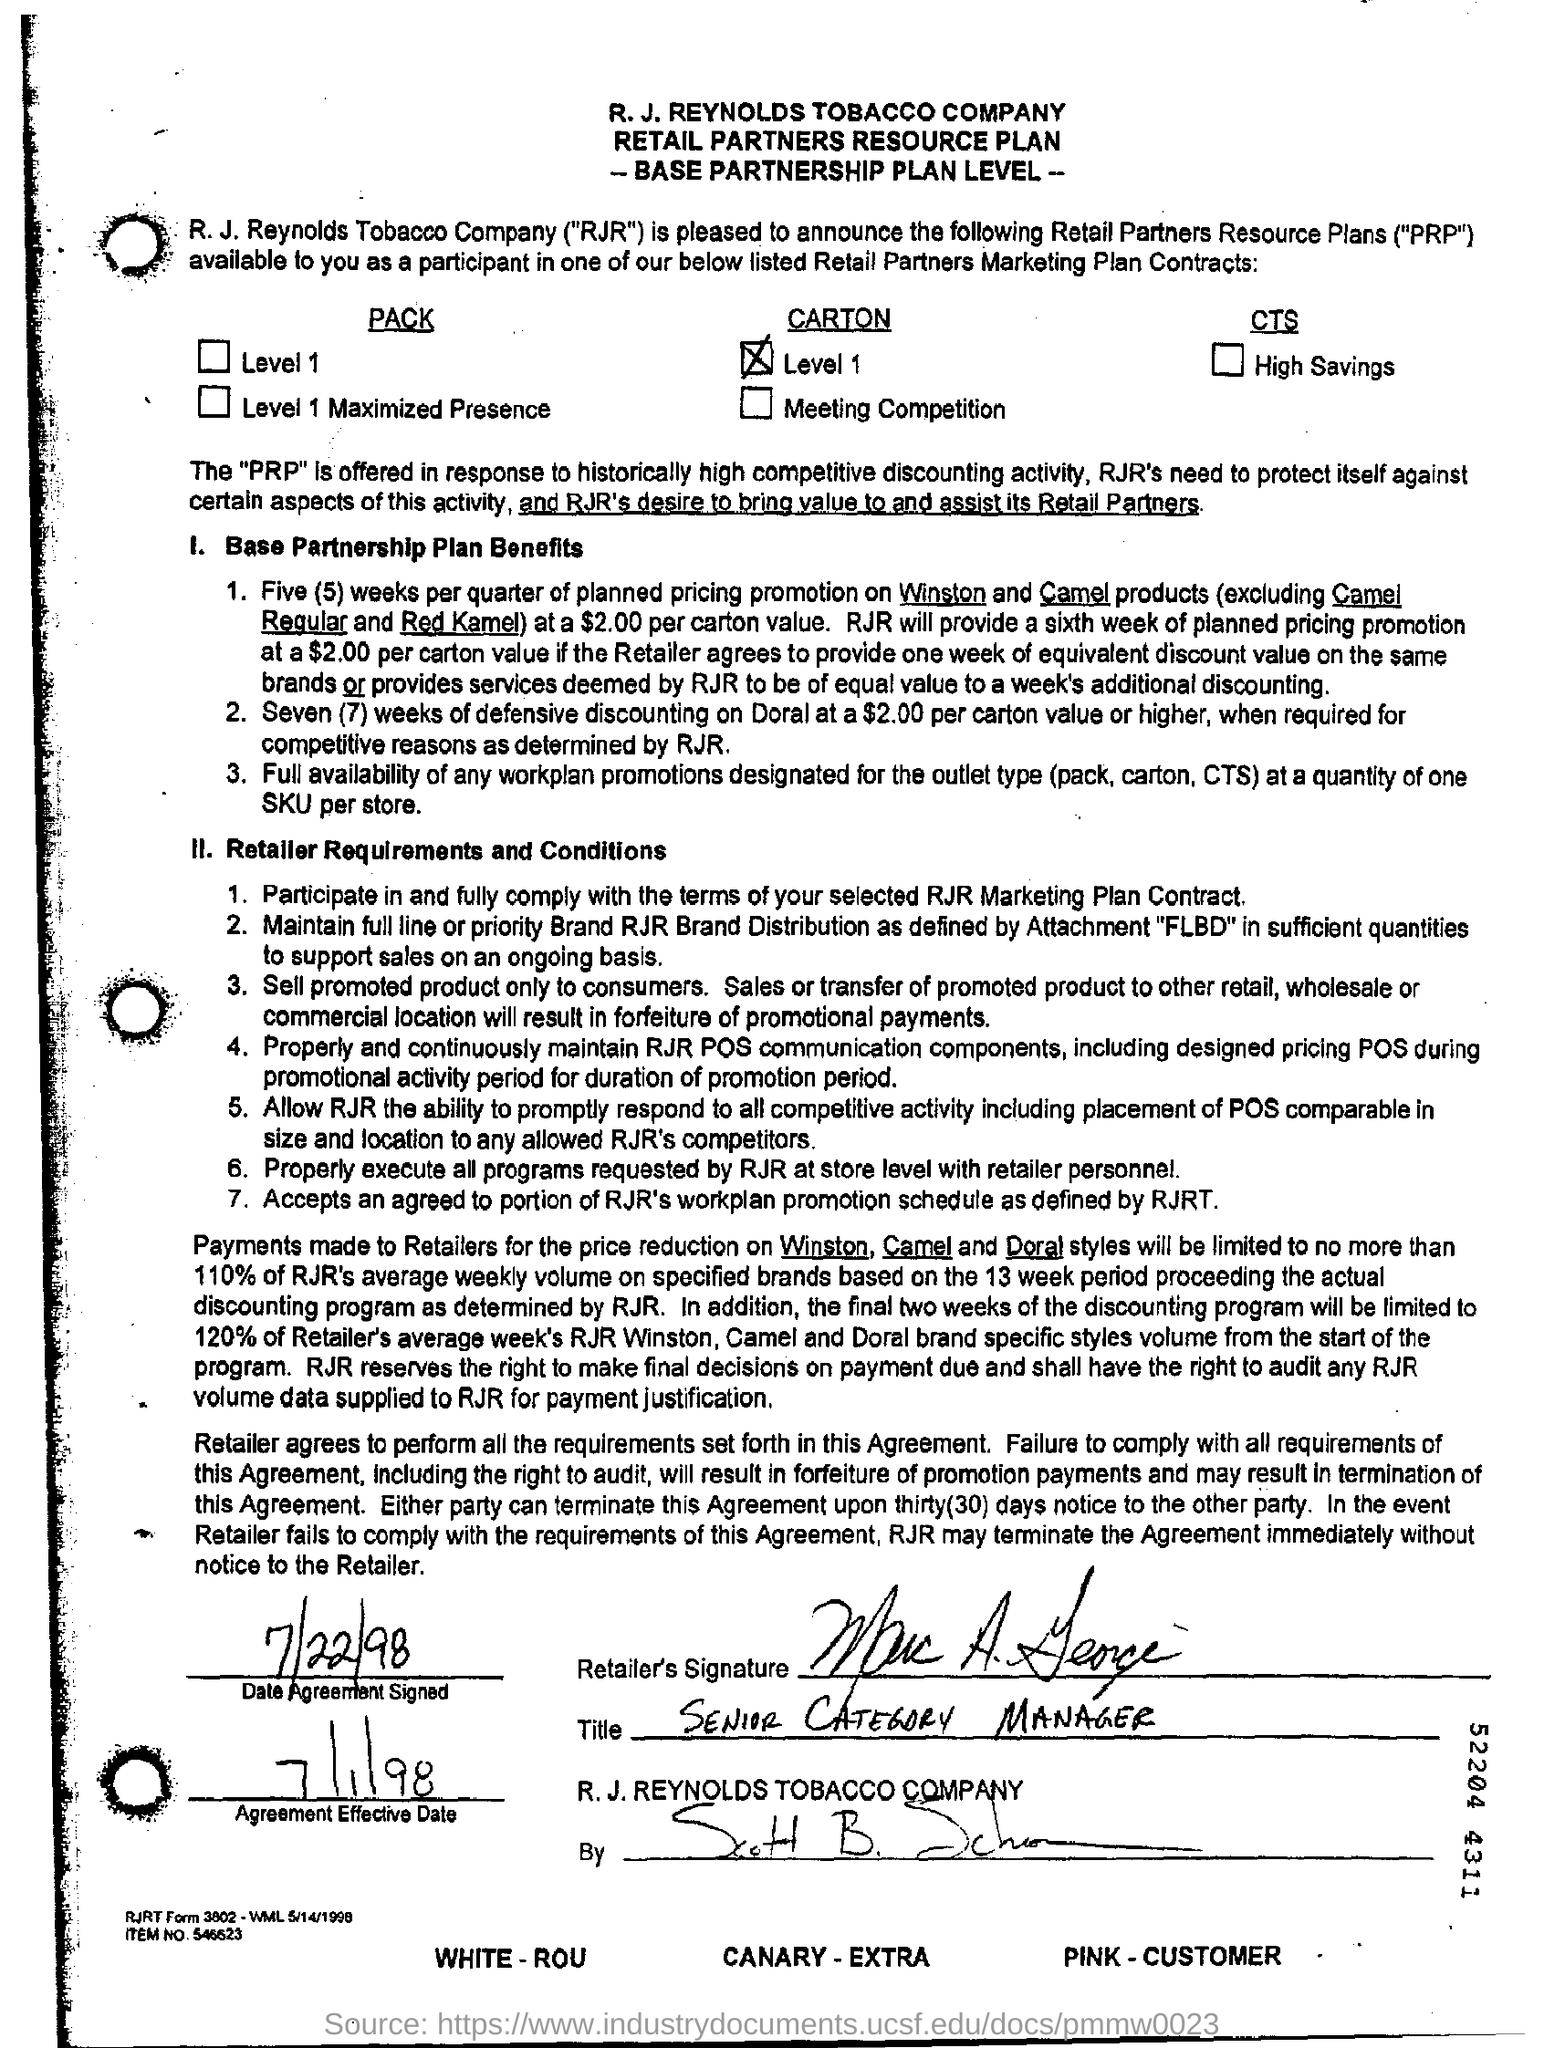When was the Agreement Signed?
Provide a succinct answer. 7/22/98. What is the name of the company?
Provide a succinct answer. R. J. Reynolds Tobacco Company. What is the Agreement Effective date?
Provide a succinct answer. 7/1/98. What is the Title of the Retailer?
Your answer should be very brief. SENIOR CATEGORY MANAGER. 